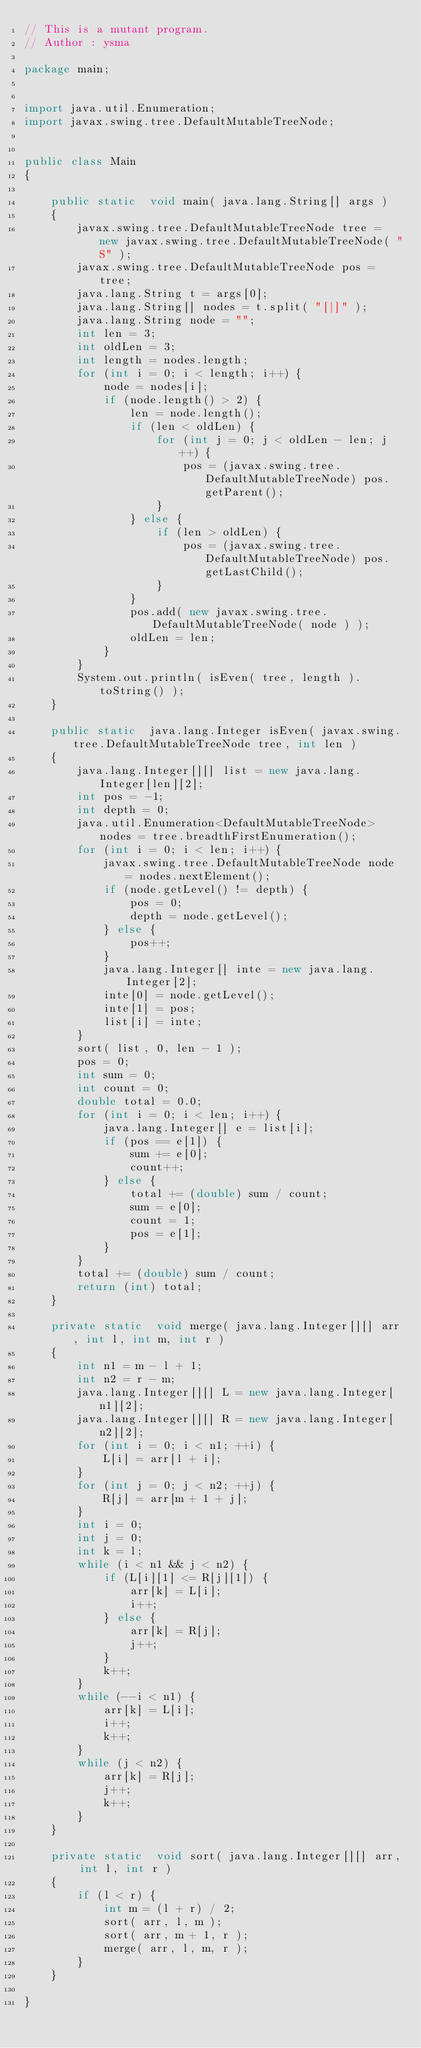<code> <loc_0><loc_0><loc_500><loc_500><_Java_>// This is a mutant program.
// Author : ysma

package main;


import java.util.Enumeration;
import javax.swing.tree.DefaultMutableTreeNode;


public class Main
{

    public static  void main( java.lang.String[] args )
    {
        javax.swing.tree.DefaultMutableTreeNode tree = new javax.swing.tree.DefaultMutableTreeNode( "S" );
        javax.swing.tree.DefaultMutableTreeNode pos = tree;
        java.lang.String t = args[0];
        java.lang.String[] nodes = t.split( "[|]" );
        java.lang.String node = "";
        int len = 3;
        int oldLen = 3;
        int length = nodes.length;
        for (int i = 0; i < length; i++) {
            node = nodes[i];
            if (node.length() > 2) {
                len = node.length();
                if (len < oldLen) {
                    for (int j = 0; j < oldLen - len; j++) {
                        pos = (javax.swing.tree.DefaultMutableTreeNode) pos.getParent();
                    }
                } else {
                    if (len > oldLen) {
                        pos = (javax.swing.tree.DefaultMutableTreeNode) pos.getLastChild();
                    }
                }
                pos.add( new javax.swing.tree.DefaultMutableTreeNode( node ) );
                oldLen = len;
            }
        }
        System.out.println( isEven( tree, length ).toString() );
    }

    public static  java.lang.Integer isEven( javax.swing.tree.DefaultMutableTreeNode tree, int len )
    {
        java.lang.Integer[][] list = new java.lang.Integer[len][2];
        int pos = -1;
        int depth = 0;
        java.util.Enumeration<DefaultMutableTreeNode> nodes = tree.breadthFirstEnumeration();
        for (int i = 0; i < len; i++) {
            javax.swing.tree.DefaultMutableTreeNode node = nodes.nextElement();
            if (node.getLevel() != depth) {
                pos = 0;
                depth = node.getLevel();
            } else {
                pos++;
            }
            java.lang.Integer[] inte = new java.lang.Integer[2];
            inte[0] = node.getLevel();
            inte[1] = pos;
            list[i] = inte;
        }
        sort( list, 0, len - 1 );
        pos = 0;
        int sum = 0;
        int count = 0;
        double total = 0.0;
        for (int i = 0; i < len; i++) {
            java.lang.Integer[] e = list[i];
            if (pos == e[1]) {
                sum += e[0];
                count++;
            } else {
                total += (double) sum / count;
                sum = e[0];
                count = 1;
                pos = e[1];
            }
        }
        total += (double) sum / count;
        return (int) total;
    }

    private static  void merge( java.lang.Integer[][] arr, int l, int m, int r )
    {
        int n1 = m - l + 1;
        int n2 = r - m;
        java.lang.Integer[][] L = new java.lang.Integer[n1][2];
        java.lang.Integer[][] R = new java.lang.Integer[n2][2];
        for (int i = 0; i < n1; ++i) {
            L[i] = arr[l + i];
        }
        for (int j = 0; j < n2; ++j) {
            R[j] = arr[m + 1 + j];
        }
        int i = 0;
        int j = 0;
        int k = l;
        while (i < n1 && j < n2) {
            if (L[i][1] <= R[j][1]) {
                arr[k] = L[i];
                i++;
            } else {
                arr[k] = R[j];
                j++;
            }
            k++;
        }
        while (--i < n1) {
            arr[k] = L[i];
            i++;
            k++;
        }
        while (j < n2) {
            arr[k] = R[j];
            j++;
            k++;
        }
    }

    private static  void sort( java.lang.Integer[][] arr, int l, int r )
    {
        if (l < r) {
            int m = (l + r) / 2;
            sort( arr, l, m );
            sort( arr, m + 1, r );
            merge( arr, l, m, r );
        }
    }

}
</code> 